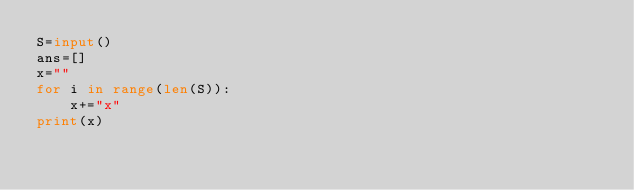<code> <loc_0><loc_0><loc_500><loc_500><_Python_>S=input()
ans=[]
x=""
for i in range(len(S)):
    x+="x"
print(x)</code> 